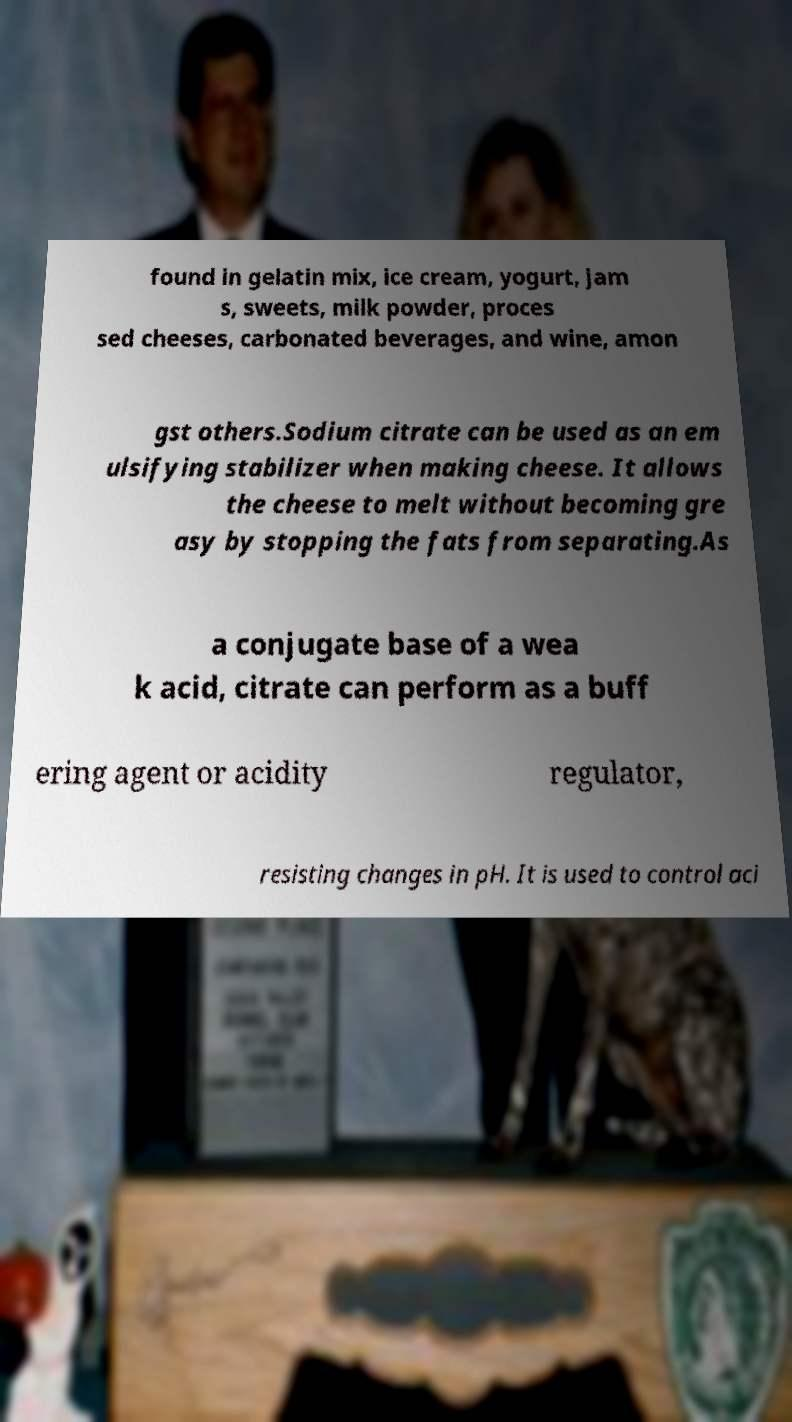Could you assist in decoding the text presented in this image and type it out clearly? found in gelatin mix, ice cream, yogurt, jam s, sweets, milk powder, proces sed cheeses, carbonated beverages, and wine, amon gst others.Sodium citrate can be used as an em ulsifying stabilizer when making cheese. It allows the cheese to melt without becoming gre asy by stopping the fats from separating.As a conjugate base of a wea k acid, citrate can perform as a buff ering agent or acidity regulator, resisting changes in pH. It is used to control aci 